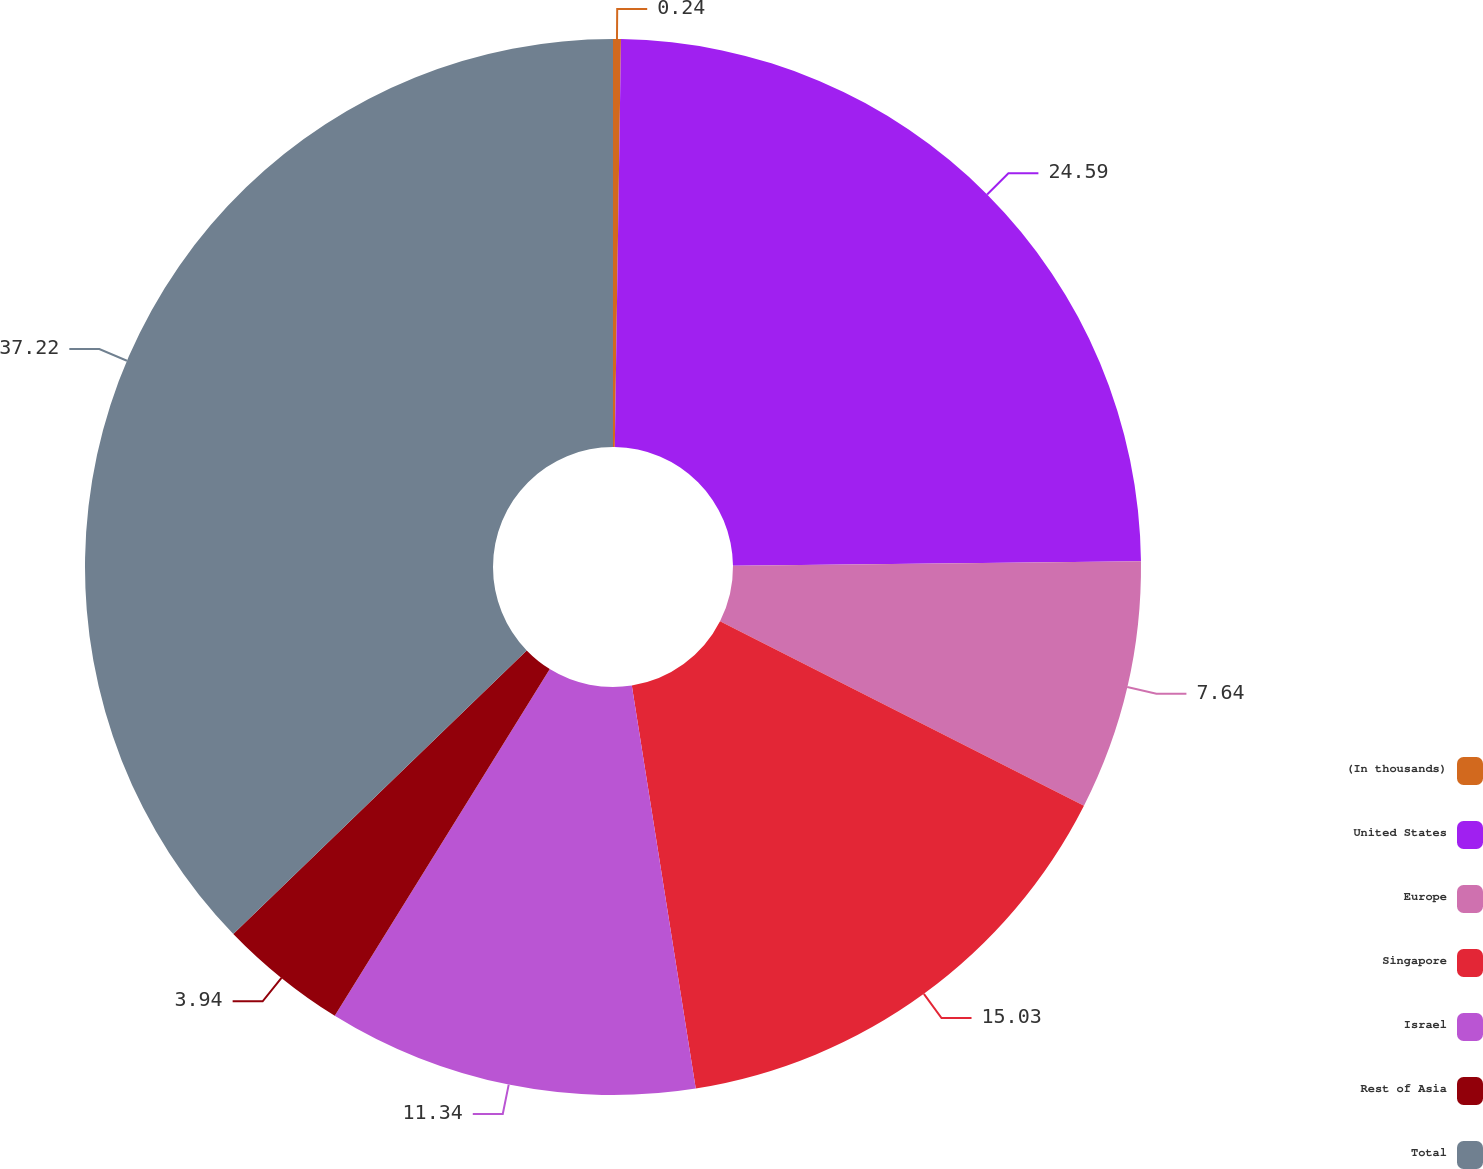<chart> <loc_0><loc_0><loc_500><loc_500><pie_chart><fcel>(In thousands)<fcel>United States<fcel>Europe<fcel>Singapore<fcel>Israel<fcel>Rest of Asia<fcel>Total<nl><fcel>0.24%<fcel>24.59%<fcel>7.64%<fcel>15.03%<fcel>11.34%<fcel>3.94%<fcel>37.23%<nl></chart> 